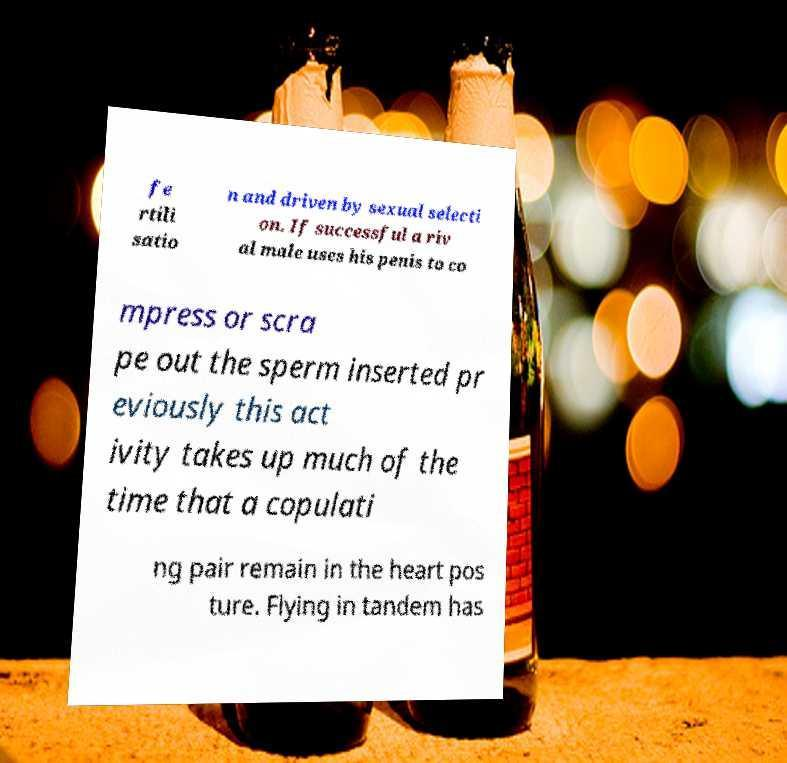I need the written content from this picture converted into text. Can you do that? fe rtili satio n and driven by sexual selecti on. If successful a riv al male uses his penis to co mpress or scra pe out the sperm inserted pr eviously this act ivity takes up much of the time that a copulati ng pair remain in the heart pos ture. Flying in tandem has 